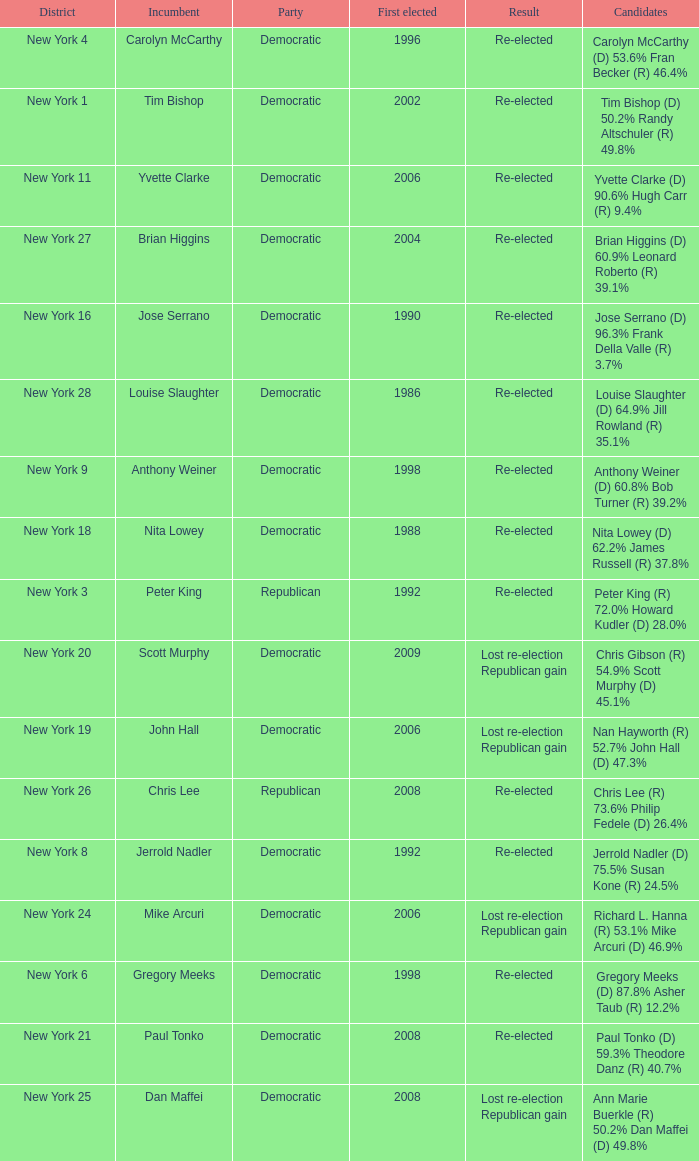Name the result for new york 8 Re-elected. 